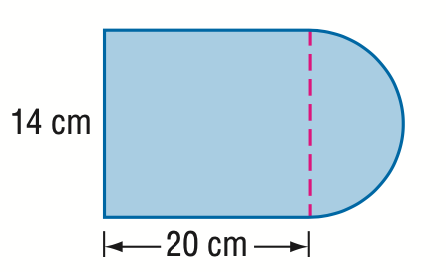Answer the mathemtical geometry problem and directly provide the correct option letter.
Question: Find the area of the composite figure. Round to the nearest tenth.
Choices: A: 217.0 B: 293.9 C: 357.0 D: 433.9 C 